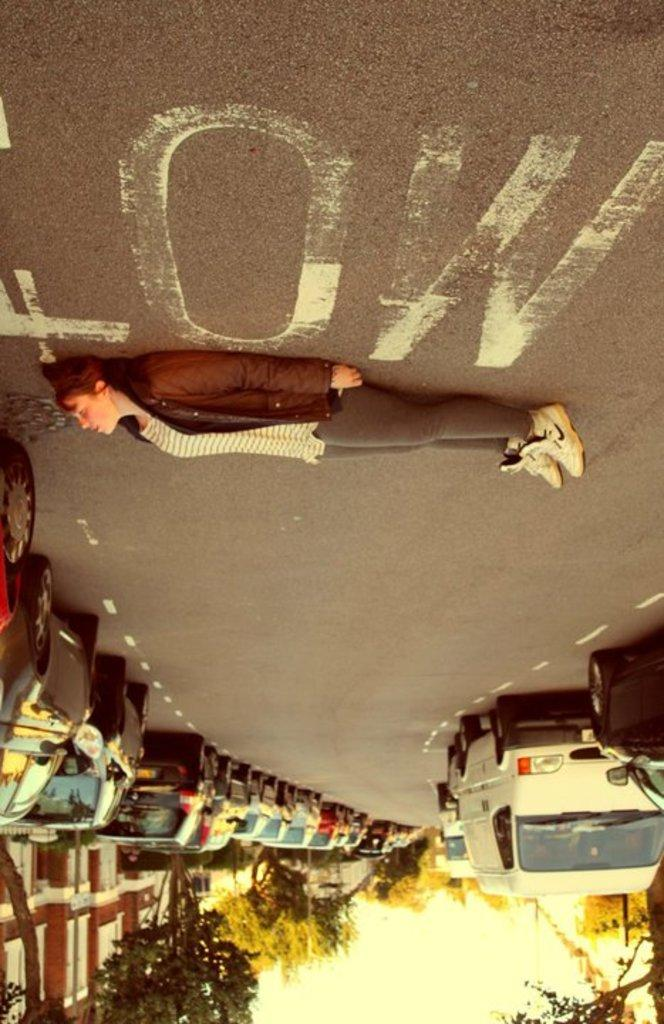Who is present in the image? There is a woman in the image. What can be seen on the road in the image? There are vehicles on the road in the image. What type of natural elements are visible in the image? There are trees in the image. What type of man-made structures are visible in the image? There are buildings in the image. What type of discovery is being made by the woman in the image? There is no indication of a discovery being made in the image. The woman's actions or expressions do not suggest any discovery or exploration. 